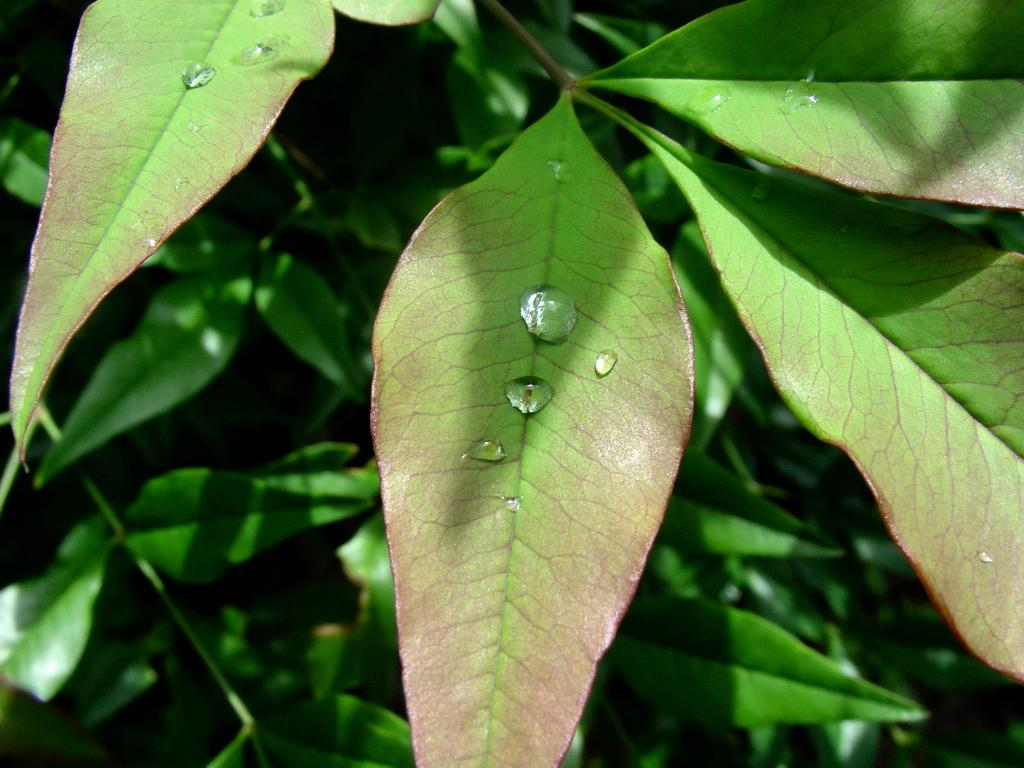What type of vegetation can be seen in the image? There are leaves in the image. What time does the moon appear in the image? There is no moon present in the image; it only features leaves. Who is the representative of the group in the image? There is no group or representative present in the image; it only features leaves. 